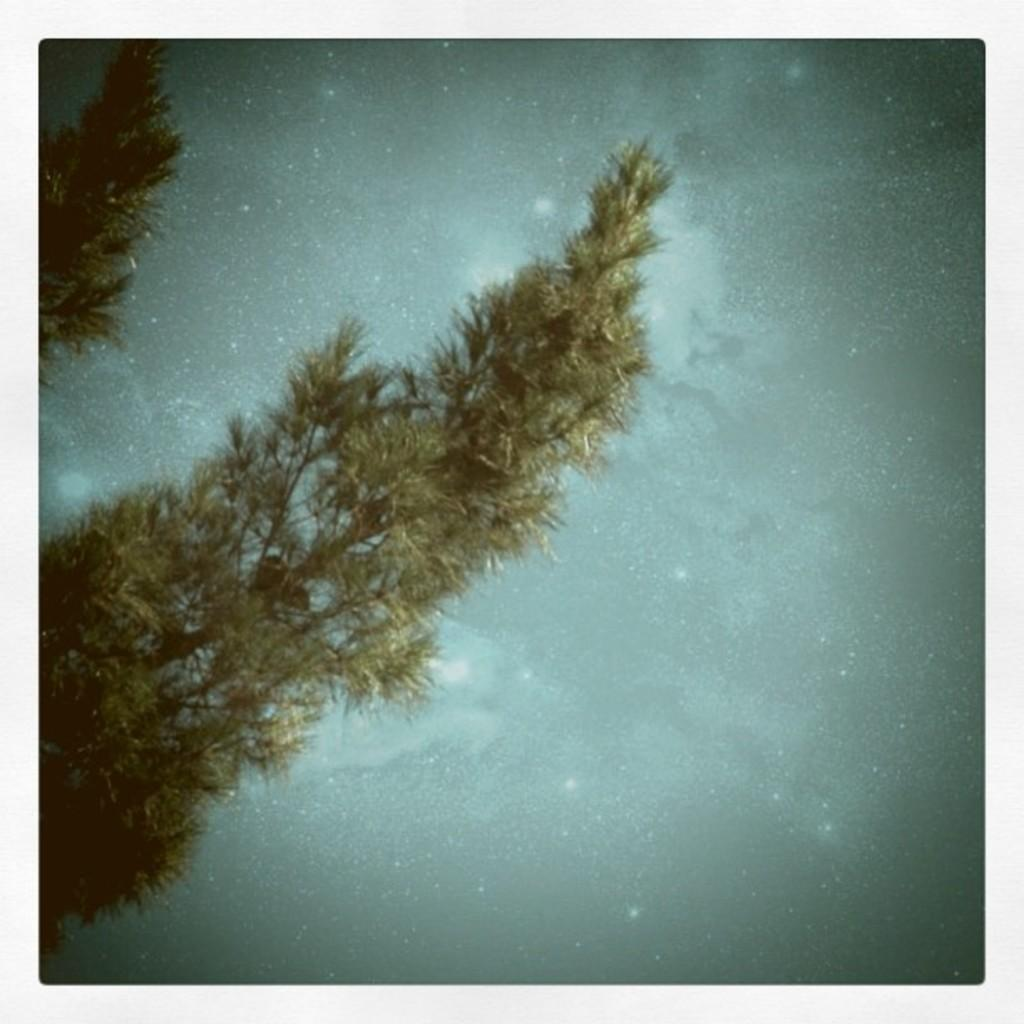How many trees are present in the image? There are two trees in the image. Can you describe the location of the first tree? One tree is in the top left corner of the image. Where is the second tree located? Another tree is in the middle of the image. What type of zephyr can be seen blowing through the branches of the trees in the image? There is no zephyr present in the image; it is a still image of trees. 